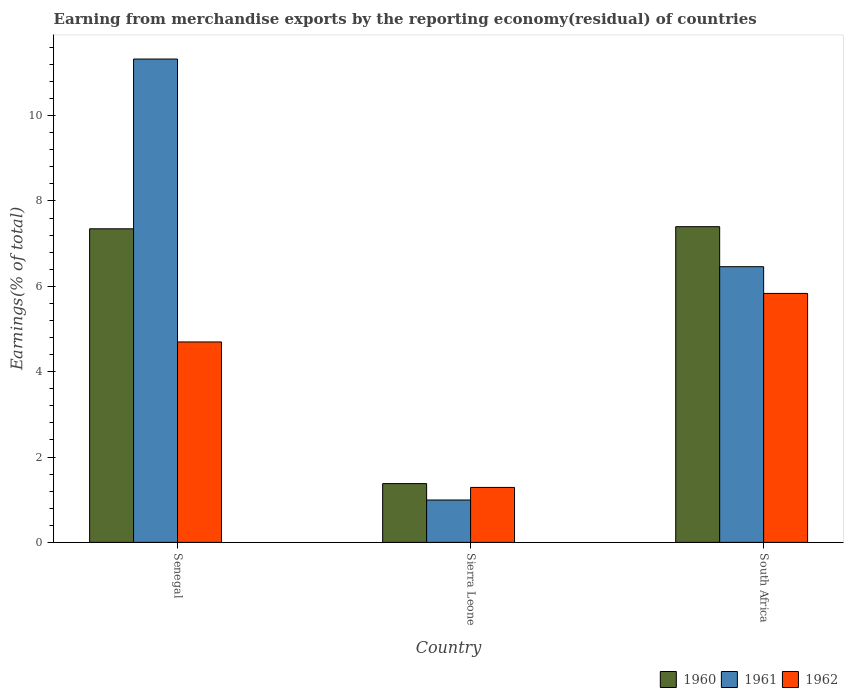Are the number of bars on each tick of the X-axis equal?
Provide a short and direct response. Yes. How many bars are there on the 3rd tick from the left?
Provide a succinct answer. 3. What is the label of the 1st group of bars from the left?
Keep it short and to the point. Senegal. In how many cases, is the number of bars for a given country not equal to the number of legend labels?
Ensure brevity in your answer.  0. What is the percentage of amount earned from merchandise exports in 1960 in Senegal?
Your response must be concise. 7.35. Across all countries, what is the maximum percentage of amount earned from merchandise exports in 1960?
Give a very brief answer. 7.4. Across all countries, what is the minimum percentage of amount earned from merchandise exports in 1960?
Keep it short and to the point. 1.38. In which country was the percentage of amount earned from merchandise exports in 1960 maximum?
Offer a terse response. South Africa. In which country was the percentage of amount earned from merchandise exports in 1961 minimum?
Keep it short and to the point. Sierra Leone. What is the total percentage of amount earned from merchandise exports in 1961 in the graph?
Offer a very short reply. 18.78. What is the difference between the percentage of amount earned from merchandise exports in 1960 in Senegal and that in South Africa?
Your response must be concise. -0.05. What is the difference between the percentage of amount earned from merchandise exports in 1962 in Sierra Leone and the percentage of amount earned from merchandise exports in 1960 in Senegal?
Provide a short and direct response. -6.06. What is the average percentage of amount earned from merchandise exports in 1961 per country?
Your response must be concise. 6.26. What is the difference between the percentage of amount earned from merchandise exports of/in 1960 and percentage of amount earned from merchandise exports of/in 1961 in Senegal?
Your response must be concise. -3.98. What is the ratio of the percentage of amount earned from merchandise exports in 1962 in Senegal to that in Sierra Leone?
Your response must be concise. 3.65. What is the difference between the highest and the second highest percentage of amount earned from merchandise exports in 1960?
Keep it short and to the point. -5.97. What is the difference between the highest and the lowest percentage of amount earned from merchandise exports in 1960?
Keep it short and to the point. 6.02. In how many countries, is the percentage of amount earned from merchandise exports in 1961 greater than the average percentage of amount earned from merchandise exports in 1961 taken over all countries?
Your answer should be very brief. 2. Is the sum of the percentage of amount earned from merchandise exports in 1962 in Sierra Leone and South Africa greater than the maximum percentage of amount earned from merchandise exports in 1960 across all countries?
Offer a very short reply. No. Is it the case that in every country, the sum of the percentage of amount earned from merchandise exports in 1961 and percentage of amount earned from merchandise exports in 1960 is greater than the percentage of amount earned from merchandise exports in 1962?
Keep it short and to the point. Yes. Does the graph contain grids?
Offer a terse response. No. Where does the legend appear in the graph?
Give a very brief answer. Bottom right. How many legend labels are there?
Offer a terse response. 3. What is the title of the graph?
Give a very brief answer. Earning from merchandise exports by the reporting economy(residual) of countries. Does "2004" appear as one of the legend labels in the graph?
Keep it short and to the point. No. What is the label or title of the Y-axis?
Offer a very short reply. Earnings(% of total). What is the Earnings(% of total) of 1960 in Senegal?
Provide a short and direct response. 7.35. What is the Earnings(% of total) in 1961 in Senegal?
Provide a short and direct response. 11.33. What is the Earnings(% of total) in 1962 in Senegal?
Offer a terse response. 4.7. What is the Earnings(% of total) of 1960 in Sierra Leone?
Make the answer very short. 1.38. What is the Earnings(% of total) in 1961 in Sierra Leone?
Offer a terse response. 0.99. What is the Earnings(% of total) of 1962 in Sierra Leone?
Your answer should be compact. 1.29. What is the Earnings(% of total) in 1960 in South Africa?
Your answer should be compact. 7.4. What is the Earnings(% of total) of 1961 in South Africa?
Make the answer very short. 6.46. What is the Earnings(% of total) in 1962 in South Africa?
Provide a succinct answer. 5.83. Across all countries, what is the maximum Earnings(% of total) of 1960?
Your response must be concise. 7.4. Across all countries, what is the maximum Earnings(% of total) in 1961?
Keep it short and to the point. 11.33. Across all countries, what is the maximum Earnings(% of total) of 1962?
Offer a terse response. 5.83. Across all countries, what is the minimum Earnings(% of total) in 1960?
Make the answer very short. 1.38. Across all countries, what is the minimum Earnings(% of total) of 1961?
Provide a succinct answer. 0.99. Across all countries, what is the minimum Earnings(% of total) of 1962?
Your answer should be very brief. 1.29. What is the total Earnings(% of total) of 1960 in the graph?
Provide a short and direct response. 16.12. What is the total Earnings(% of total) in 1961 in the graph?
Keep it short and to the point. 18.78. What is the total Earnings(% of total) in 1962 in the graph?
Your response must be concise. 11.82. What is the difference between the Earnings(% of total) of 1960 in Senegal and that in Sierra Leone?
Give a very brief answer. 5.97. What is the difference between the Earnings(% of total) in 1961 in Senegal and that in Sierra Leone?
Give a very brief answer. 10.33. What is the difference between the Earnings(% of total) of 1962 in Senegal and that in Sierra Leone?
Your answer should be very brief. 3.41. What is the difference between the Earnings(% of total) in 1960 in Senegal and that in South Africa?
Give a very brief answer. -0.05. What is the difference between the Earnings(% of total) of 1961 in Senegal and that in South Africa?
Provide a succinct answer. 4.87. What is the difference between the Earnings(% of total) in 1962 in Senegal and that in South Africa?
Make the answer very short. -1.14. What is the difference between the Earnings(% of total) in 1960 in Sierra Leone and that in South Africa?
Keep it short and to the point. -6.02. What is the difference between the Earnings(% of total) of 1961 in Sierra Leone and that in South Africa?
Your answer should be very brief. -5.47. What is the difference between the Earnings(% of total) in 1962 in Sierra Leone and that in South Africa?
Your answer should be compact. -4.55. What is the difference between the Earnings(% of total) of 1960 in Senegal and the Earnings(% of total) of 1961 in Sierra Leone?
Offer a terse response. 6.35. What is the difference between the Earnings(% of total) in 1960 in Senegal and the Earnings(% of total) in 1962 in Sierra Leone?
Your answer should be very brief. 6.06. What is the difference between the Earnings(% of total) of 1961 in Senegal and the Earnings(% of total) of 1962 in Sierra Leone?
Offer a terse response. 10.04. What is the difference between the Earnings(% of total) of 1960 in Senegal and the Earnings(% of total) of 1961 in South Africa?
Offer a terse response. 0.89. What is the difference between the Earnings(% of total) in 1960 in Senegal and the Earnings(% of total) in 1962 in South Africa?
Provide a succinct answer. 1.51. What is the difference between the Earnings(% of total) in 1961 in Senegal and the Earnings(% of total) in 1962 in South Africa?
Offer a very short reply. 5.49. What is the difference between the Earnings(% of total) of 1960 in Sierra Leone and the Earnings(% of total) of 1961 in South Africa?
Keep it short and to the point. -5.08. What is the difference between the Earnings(% of total) of 1960 in Sierra Leone and the Earnings(% of total) of 1962 in South Africa?
Offer a terse response. -4.46. What is the difference between the Earnings(% of total) in 1961 in Sierra Leone and the Earnings(% of total) in 1962 in South Africa?
Ensure brevity in your answer.  -4.84. What is the average Earnings(% of total) in 1960 per country?
Give a very brief answer. 5.37. What is the average Earnings(% of total) of 1961 per country?
Give a very brief answer. 6.26. What is the average Earnings(% of total) in 1962 per country?
Your answer should be very brief. 3.94. What is the difference between the Earnings(% of total) in 1960 and Earnings(% of total) in 1961 in Senegal?
Give a very brief answer. -3.98. What is the difference between the Earnings(% of total) in 1960 and Earnings(% of total) in 1962 in Senegal?
Your response must be concise. 2.65. What is the difference between the Earnings(% of total) of 1961 and Earnings(% of total) of 1962 in Senegal?
Your answer should be compact. 6.63. What is the difference between the Earnings(% of total) of 1960 and Earnings(% of total) of 1961 in Sierra Leone?
Provide a succinct answer. 0.38. What is the difference between the Earnings(% of total) in 1960 and Earnings(% of total) in 1962 in Sierra Leone?
Ensure brevity in your answer.  0.09. What is the difference between the Earnings(% of total) of 1961 and Earnings(% of total) of 1962 in Sierra Leone?
Your response must be concise. -0.29. What is the difference between the Earnings(% of total) of 1960 and Earnings(% of total) of 1961 in South Africa?
Make the answer very short. 0.94. What is the difference between the Earnings(% of total) in 1960 and Earnings(% of total) in 1962 in South Africa?
Ensure brevity in your answer.  1.56. What is the difference between the Earnings(% of total) in 1961 and Earnings(% of total) in 1962 in South Africa?
Keep it short and to the point. 0.63. What is the ratio of the Earnings(% of total) in 1960 in Senegal to that in Sierra Leone?
Offer a very short reply. 5.33. What is the ratio of the Earnings(% of total) of 1961 in Senegal to that in Sierra Leone?
Ensure brevity in your answer.  11.41. What is the ratio of the Earnings(% of total) of 1962 in Senegal to that in Sierra Leone?
Give a very brief answer. 3.65. What is the ratio of the Earnings(% of total) in 1960 in Senegal to that in South Africa?
Ensure brevity in your answer.  0.99. What is the ratio of the Earnings(% of total) in 1961 in Senegal to that in South Africa?
Ensure brevity in your answer.  1.75. What is the ratio of the Earnings(% of total) in 1962 in Senegal to that in South Africa?
Ensure brevity in your answer.  0.81. What is the ratio of the Earnings(% of total) in 1960 in Sierra Leone to that in South Africa?
Make the answer very short. 0.19. What is the ratio of the Earnings(% of total) of 1961 in Sierra Leone to that in South Africa?
Give a very brief answer. 0.15. What is the ratio of the Earnings(% of total) of 1962 in Sierra Leone to that in South Africa?
Your response must be concise. 0.22. What is the difference between the highest and the second highest Earnings(% of total) in 1960?
Provide a short and direct response. 0.05. What is the difference between the highest and the second highest Earnings(% of total) of 1961?
Ensure brevity in your answer.  4.87. What is the difference between the highest and the second highest Earnings(% of total) in 1962?
Your response must be concise. 1.14. What is the difference between the highest and the lowest Earnings(% of total) of 1960?
Your response must be concise. 6.02. What is the difference between the highest and the lowest Earnings(% of total) of 1961?
Your answer should be very brief. 10.33. What is the difference between the highest and the lowest Earnings(% of total) in 1962?
Ensure brevity in your answer.  4.55. 